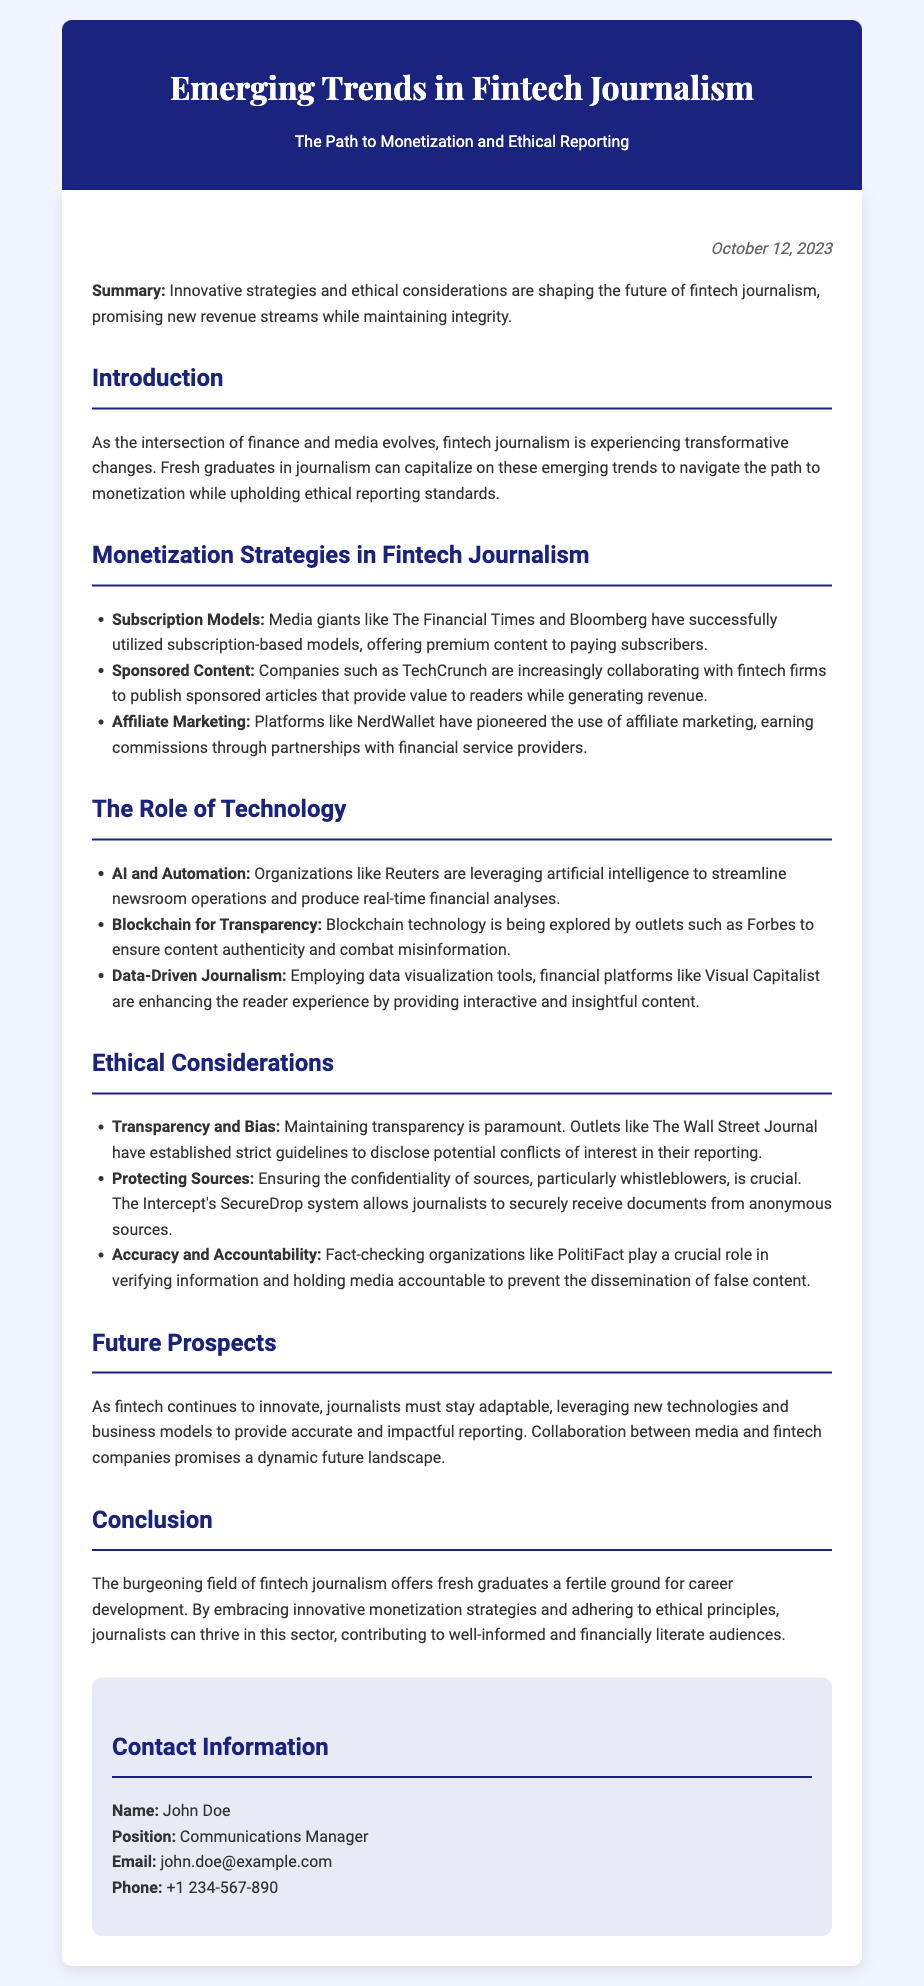What is the date of the press release? The date is mentioned at the beginning of the document following the summary section.
Answer: October 12, 2023 Who is the Communications Manager? The document lists the name and position at the end under contact information.
Answer: John Doe What model has The Financial Times utilized? The document specifically mentions their use of a subscription-based model in monetization strategies.
Answer: Subscription Models Which technology is explored by Forbes for content authenticity? The technology mentioned in the section on transparency is directly stated in connection with Forbes.
Answer: Blockchain What ethical considerations are paramount according to The Wall Street Journal? The document discusses transparency as a key ethical consideration linked to the Wall Street Journal.
Answer: Transparency What do financial platforms like Visual Capitalist enhance? The section on data-driven journalism describes what is enhanced by these platforms.
Answer: Reader experience How are journalists urged to stay in the fintech field? The conclusion highlights the need for journalists to adapt in the evolving field of fintech journalism.
Answer: Adaptable What is a crucial role played by fact-checking organizations? The document emphasizes their role in verifying information and ensuring accountability.
Answer: Verifying information 